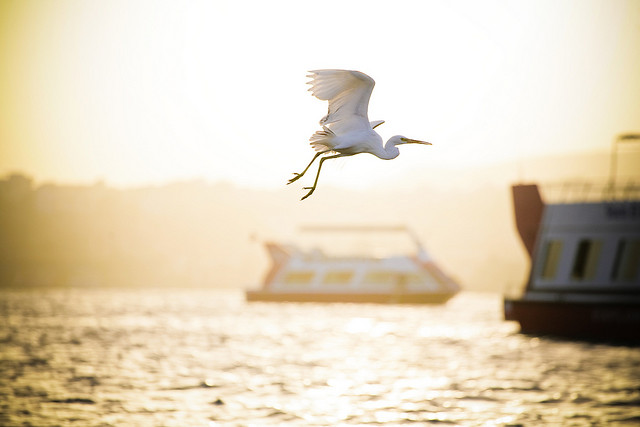Please provide the bounding box coordinate of the region this sentence describes: half boat. The bounding box coordinates for 'half boat' are [0.78, 0.37, 1.0, 0.72]. 